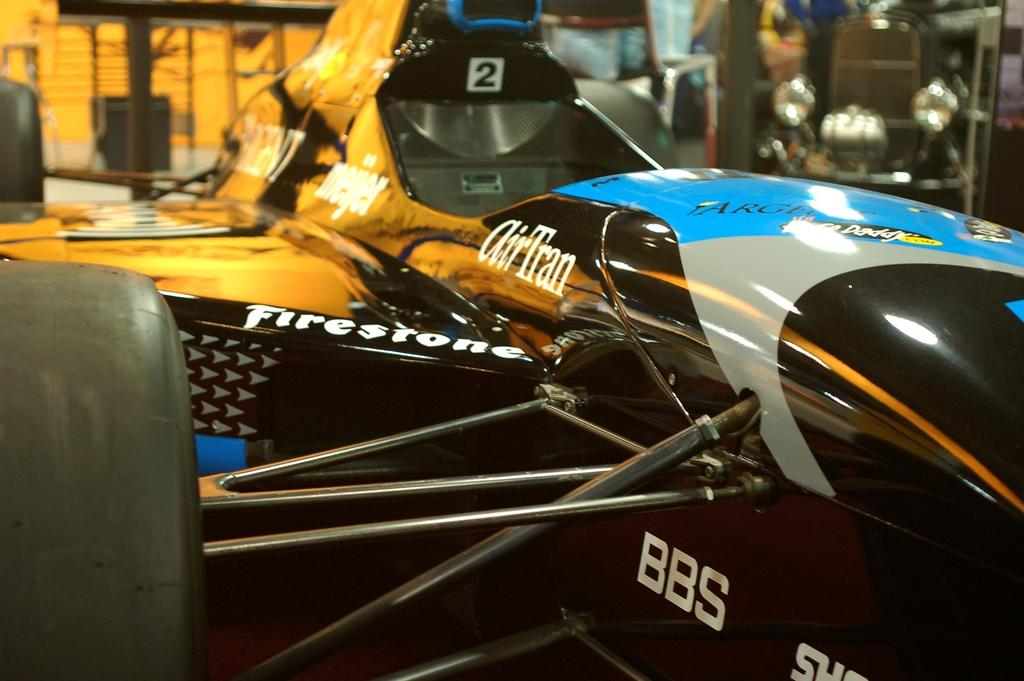What is the main subject of the image? There is a car in the image. Can you describe the background of the image? The background of the image is blurred. Are there any other cars visible in the image? Yes, there are cars visible in the background of the image. What type of chain is being used to secure the car in the image? There is no chain visible in the image; the car is not secured. What is your opinion on the design of the car in the image? The provided facts do not include any information about the design of the car, so it is not possible to provide an opinion. 